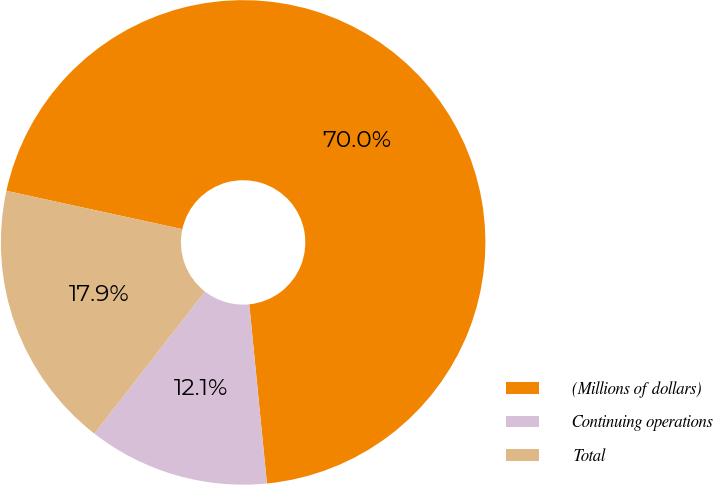Convert chart. <chart><loc_0><loc_0><loc_500><loc_500><pie_chart><fcel>(Millions of dollars)<fcel>Continuing operations<fcel>Total<nl><fcel>70.02%<fcel>12.09%<fcel>17.89%<nl></chart> 